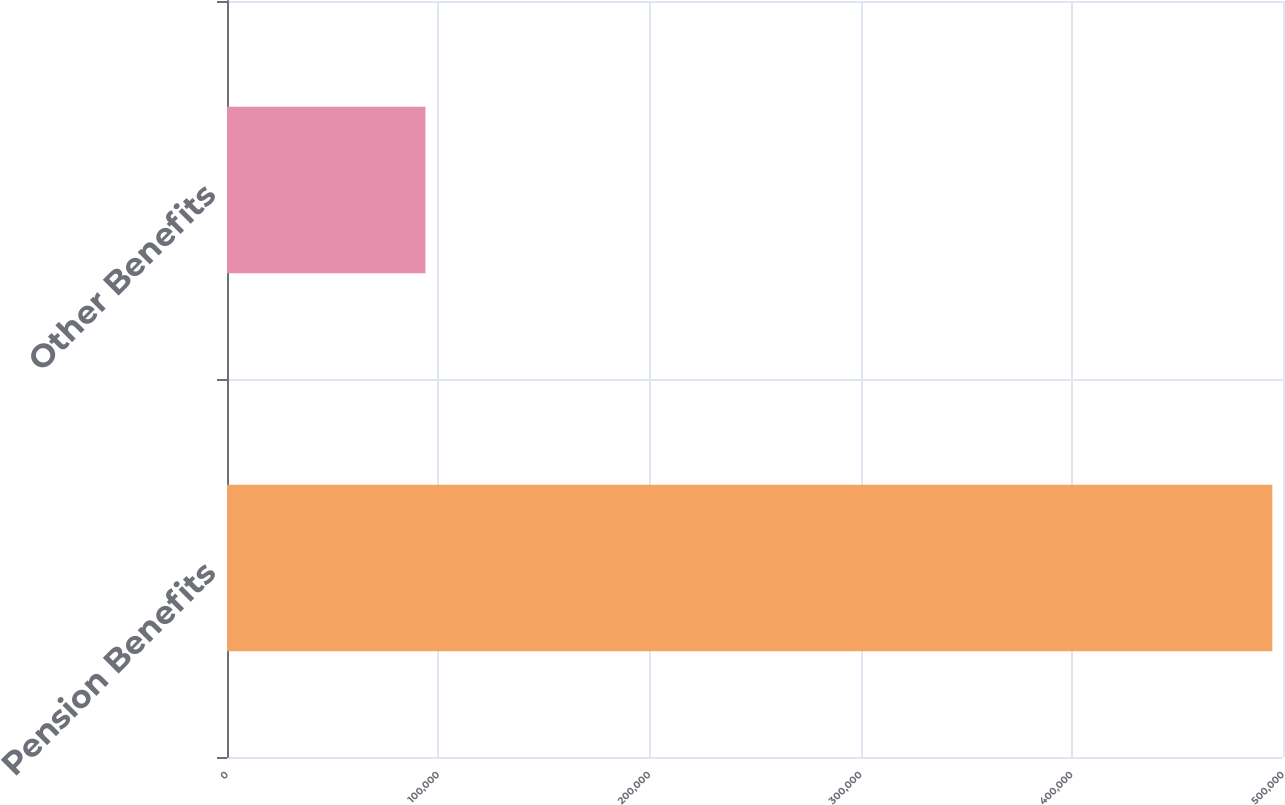Convert chart to OTSL. <chart><loc_0><loc_0><loc_500><loc_500><bar_chart><fcel>Pension Benefits<fcel>Other Benefits<nl><fcel>494946<fcel>93966<nl></chart> 